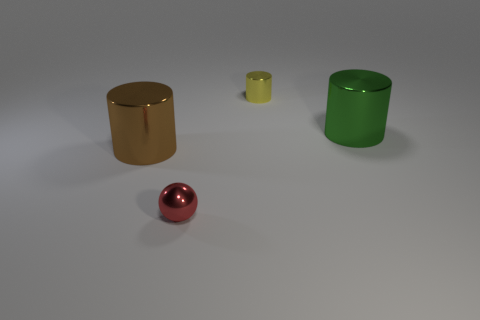Subtract all big cylinders. How many cylinders are left? 1 Add 4 big green shiny objects. How many objects exist? 8 Add 4 big green cylinders. How many big green cylinders are left? 5 Add 2 big green metallic objects. How many big green metallic objects exist? 3 Subtract all brown cylinders. How many cylinders are left? 2 Subtract 0 purple balls. How many objects are left? 4 Subtract all cylinders. How many objects are left? 1 Subtract 1 balls. How many balls are left? 0 Subtract all gray balls. Subtract all cyan cylinders. How many balls are left? 1 Subtract all cyan spheres. How many yellow cylinders are left? 1 